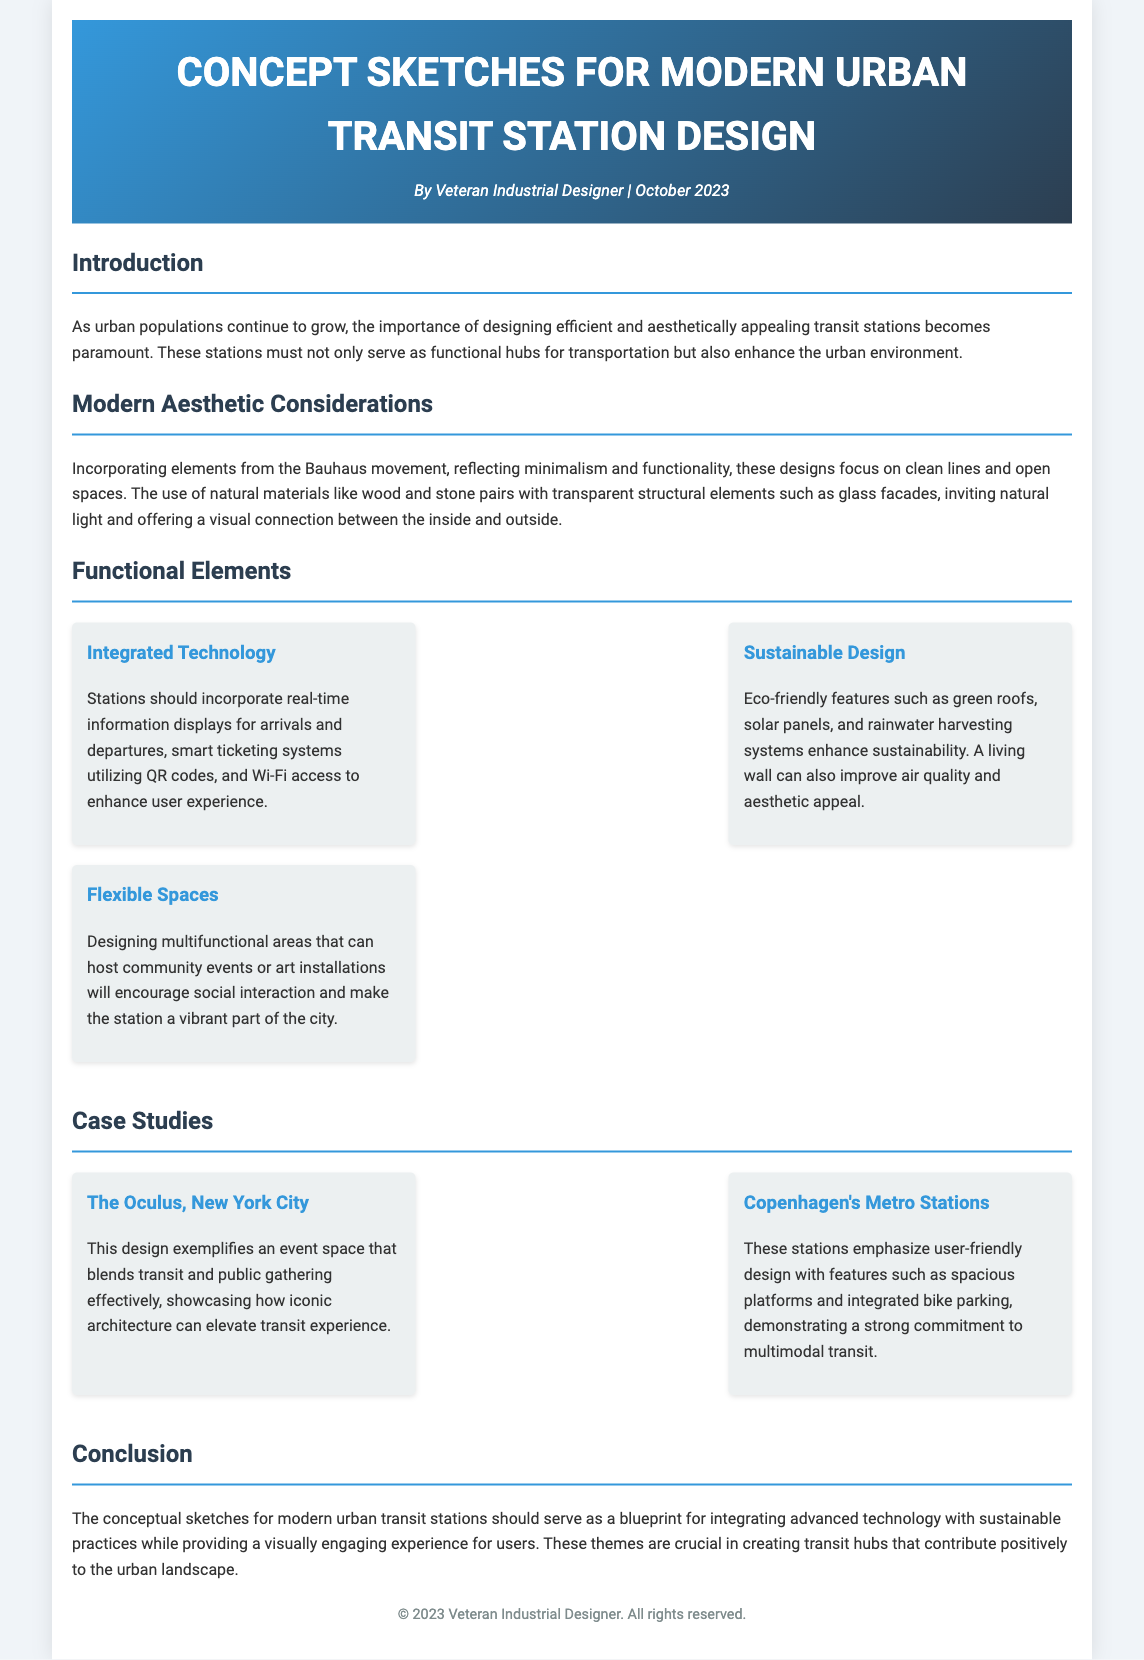What is the title of the document? The title is provided in the header of the document, which is clearly stated at the beginning.
Answer: Concept Sketches for Modern Urban Transit Station Design Who is the author of the document? The author is mentioned explicitly under the title, indicating who created the content.
Answer: Veteran Industrial Designer When was the document created? The date is provided alongside the author's name, signaling when the note was composed.
Answer: October 2023 What design movement is referenced in the modern aesthetic considerations? The document talks about influences and mentions specific movements that inform the design approach.
Answer: Bauhaus Name one functional element that enhances user experience. The document lists various elements and one specifically improves the experience of users at transit stations.
Answer: Integrated Technology What is one eco-friendly feature mentioned? The document details sustainable practices that can be integrated and mentions specific features contributing to sustainability.
Answer: Green roofs How many case studies are presented in the document? The document includes a section dedicated to practical examples, with a specific count of the case studies.
Answer: Two What city is The Oculus located in? The document references specific case studies, including their locations, making the answer explicit.
Answer: New York City What is the main focus of the transit station designs? The purpose and goals of the design work are outlined in the introduction, summarizing the main aim.
Answer: Efficiency and aesthetics 